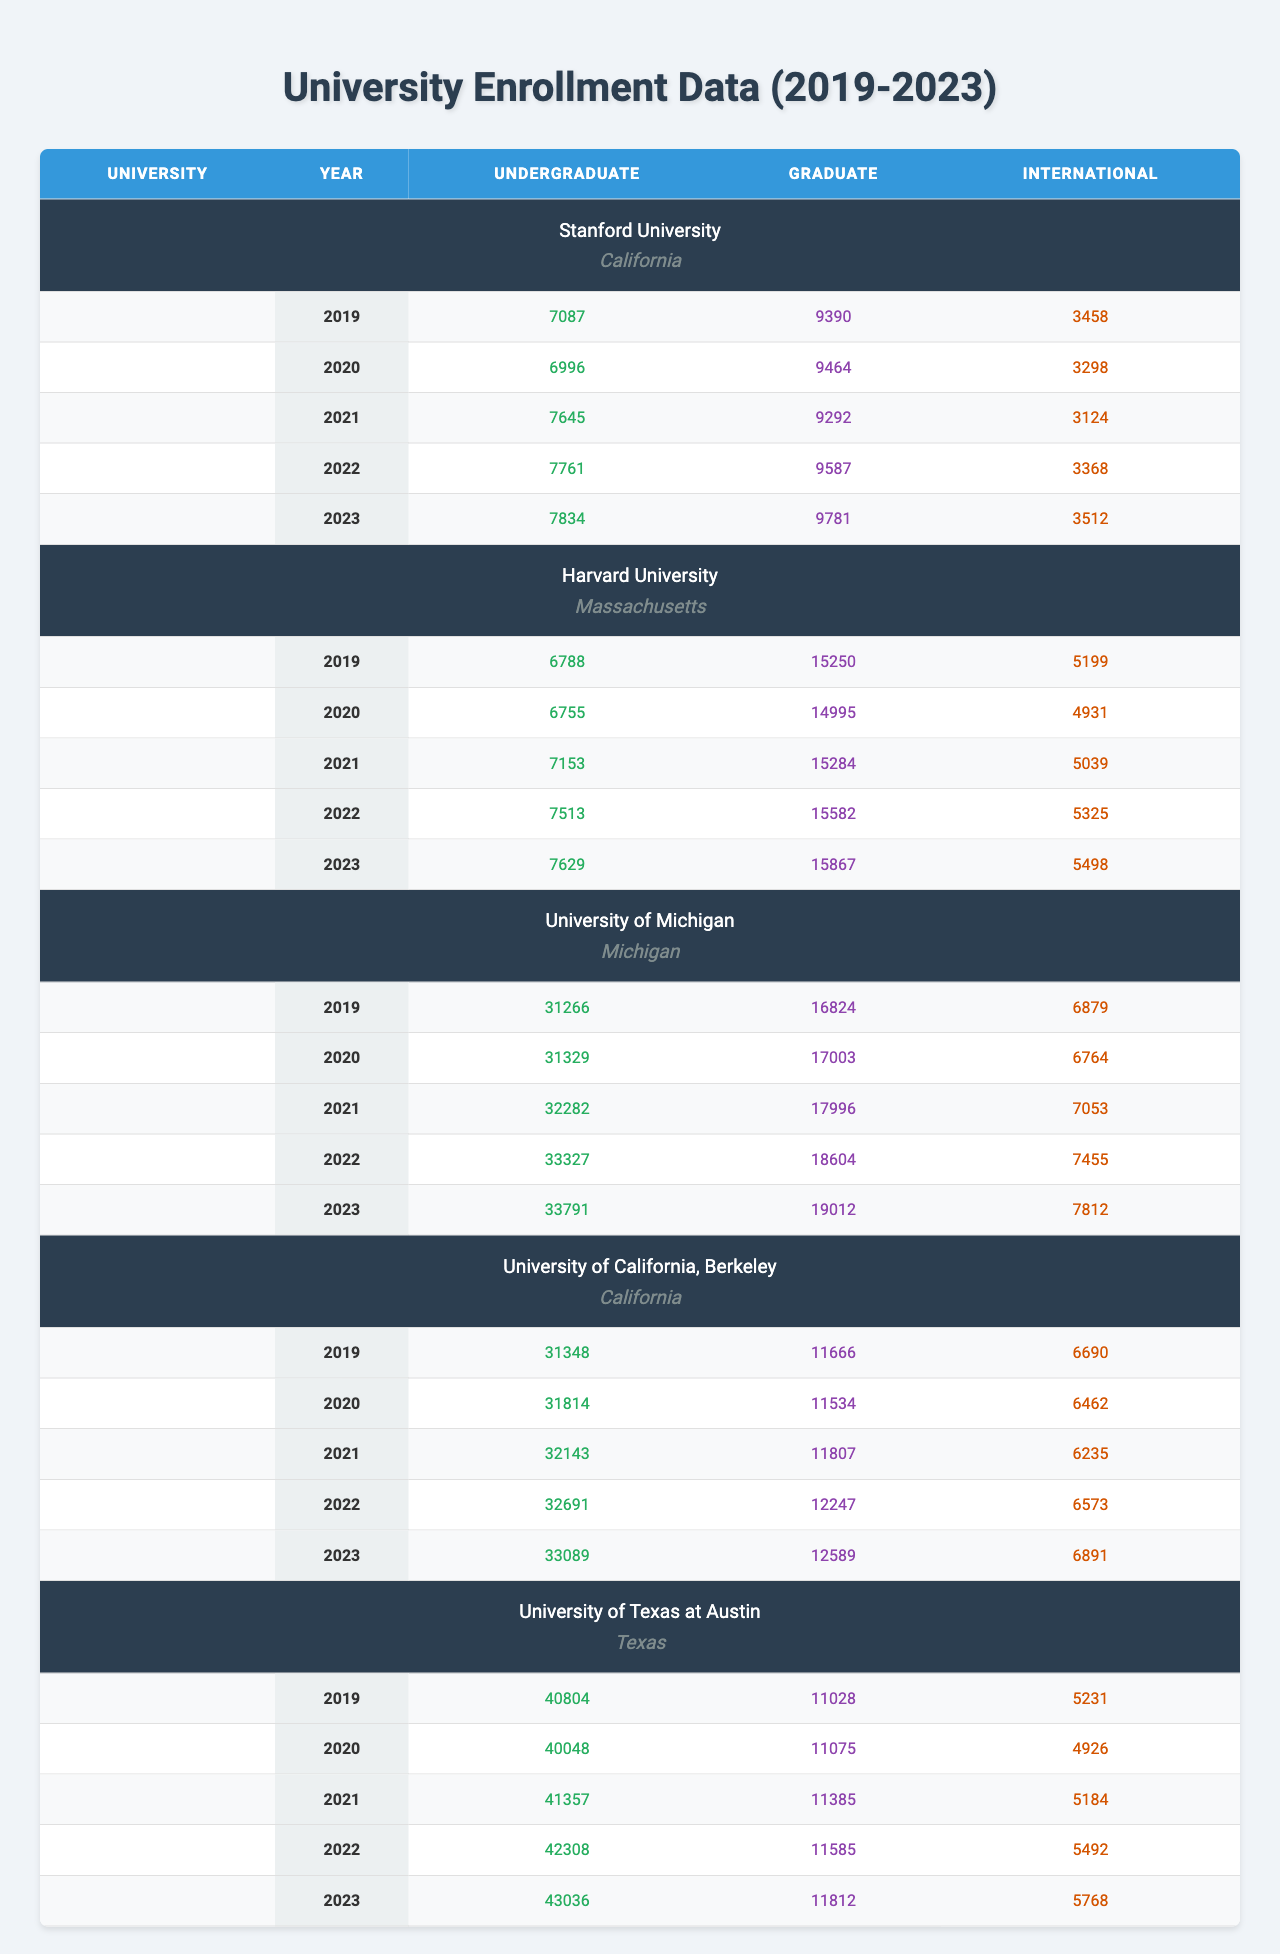What was the undergraduate enrollment at Stanford University in 2020? According to the table, the undergraduate enrollment at Stanford University in 2020 is listed under the relevant year, which shows 6996 students.
Answer: 6996 Which university had the highest international enrollment in 2023? By checking the international enrollment numbers for each university in 2023, it shows that the University of Michigan had the highest figure at 7812 students.
Answer: University of Michigan What is the total graduate enrollment for the University of Texas at Austin over the past 5 years? Summing the graduate enrollment from 2019 to 2023 gives: 11028 + 11075 + 11385 + 11585 + 11812 = 57085.
Answer: 57085 Did Harvard University's undergraduate enrollment decrease from 2019 to 2020? Comparing the figures from the table, the undergraduate enrollment for Harvard University was 6788 in 2019 and 6755 in 2020; thus, it did decrease.
Answer: Yes What was the average undergraduate enrollment at University of California, Berkeley from 2019 to 2023? The undergraduate figures from 2019 to 2023 are: 31348, 31814, 32143, 32691, 33089. The sum is 31348 + 31814 + 32143 + 32691 + 33089 = 161085. Divided by 5 gives 161085 / 5 = 32217.
Answer: 32217 Which university had the highest overall enrollment (undergrad + graduate + international) in 2021? To find the total enrollment for each university in 2021, we need to sum undergrad, graduate, and international. For University of Michigan, the total is 32282 + 17996 + 7053 = 57231; for Stanford, it's 7645 + 9292 + 3124 = 20061; for Harvard, it's 7153 + 15284 + 5039 = 27476, and for UC Berkeley, it's 32143 + 11807 + 6235 = 50285. The highest total is 57231 for the University of Michigan.
Answer: University of Michigan What was the change in international enrollment at the University of Texas at Austin from 2019 to 2023? The international enrollment for the University of Texas at Austin in 2019 was 5231, and in 2023 it was 5768. The difference is 5768 - 5231 = 537.
Answer: 537 What is the trend in Harvard University's graduate enrollment from 2019 to 2023? By observing the figures for graduate enrollment: 15250 (2019), 14995 (2020), 15284 (2021), 15582 (2022), and 15867 (2023), we see there was a decrease from 2019 to 2020, followed by an increase each subsequent year through 2023.
Answer: Increase after 2020 Which university had the smallest increase in undergraduate enrollment between 2019 and 2023? Calculating the increase for each university: Stanford went from 7087 (2019) to 7834 (2023, increase of 747); Harvard from 6788 to 7629 (841); UMich from 31266 to 33791 (1525); Berkeley from 31348 to 33089 (741); UT Austin from 40804 to 43036 (1232). The smallest increase is from Stanford with 747.
Answer: Stanford University What was the total enrollment at University of Michigan in 2022? To find the total, we add the undergraduate, graduate, and international numbers for 2022: 33327 (undergrad) + 18604 (graduate) + 7455 (international) = 59446.
Answer: 59446 